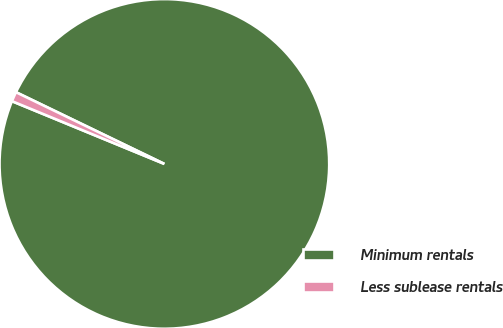Convert chart to OTSL. <chart><loc_0><loc_0><loc_500><loc_500><pie_chart><fcel>Minimum rentals<fcel>Less sublease rentals<nl><fcel>99.05%<fcel>0.95%<nl></chart> 